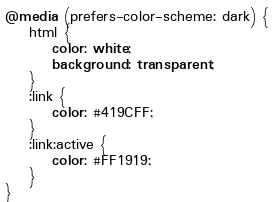Convert code to text. <code><loc_0><loc_0><loc_500><loc_500><_CSS_>@media (prefers-color-scheme: dark) {
    html {
        color: white;
        background: transparent;
    }
    :link {
        color: #419CFF;
    }
    :link:active {
        color: #FF1919;
    }
}
</code> 